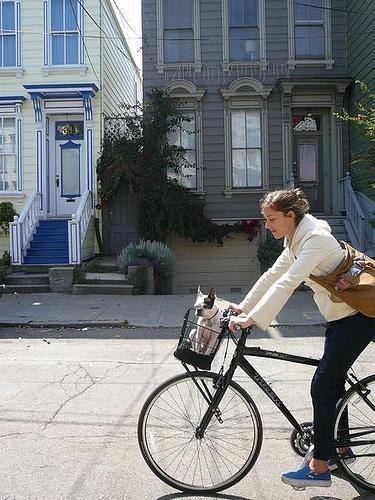How many black backpacks are seen?
Give a very brief answer. 0. How many ski poles are there?
Give a very brief answer. 0. 